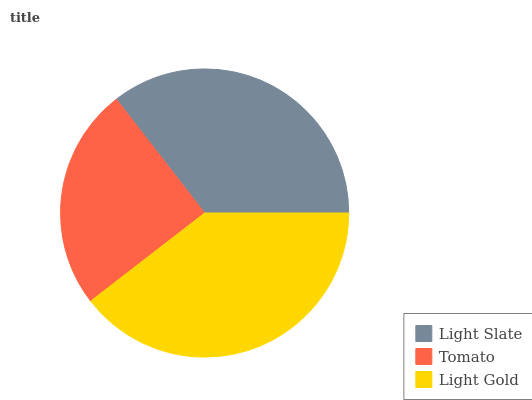Is Tomato the minimum?
Answer yes or no. Yes. Is Light Gold the maximum?
Answer yes or no. Yes. Is Light Gold the minimum?
Answer yes or no. No. Is Tomato the maximum?
Answer yes or no. No. Is Light Gold greater than Tomato?
Answer yes or no. Yes. Is Tomato less than Light Gold?
Answer yes or no. Yes. Is Tomato greater than Light Gold?
Answer yes or no. No. Is Light Gold less than Tomato?
Answer yes or no. No. Is Light Slate the high median?
Answer yes or no. Yes. Is Light Slate the low median?
Answer yes or no. Yes. Is Tomato the high median?
Answer yes or no. No. Is Tomato the low median?
Answer yes or no. No. 